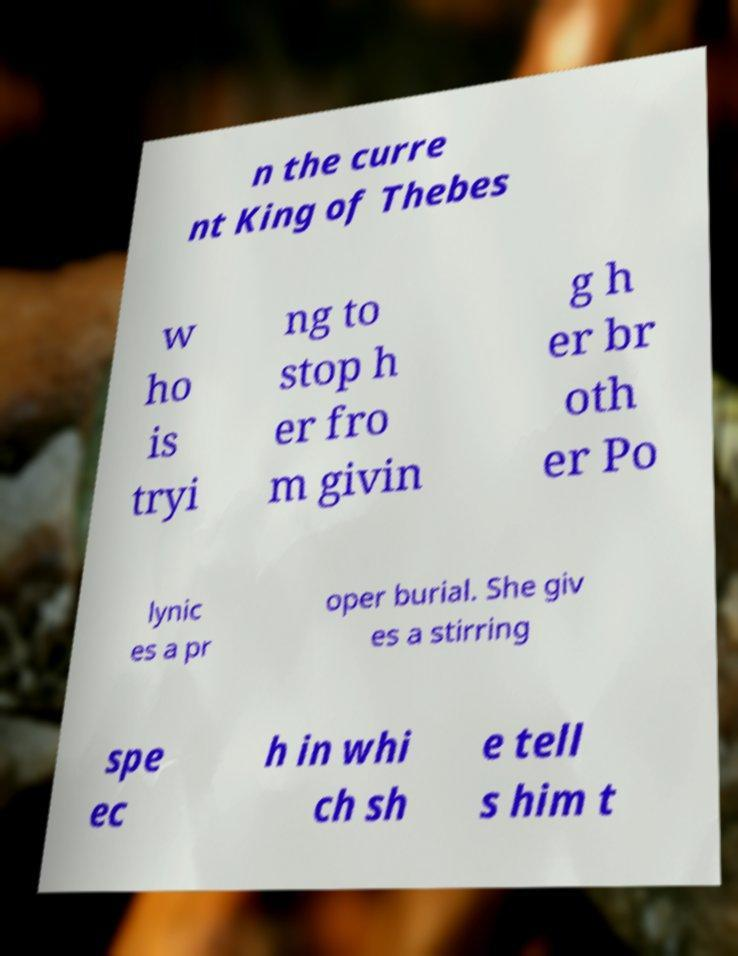For documentation purposes, I need the text within this image transcribed. Could you provide that? n the curre nt King of Thebes w ho is tryi ng to stop h er fro m givin g h er br oth er Po lynic es a pr oper burial. She giv es a stirring spe ec h in whi ch sh e tell s him t 